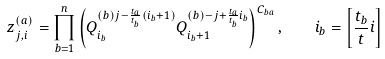<formula> <loc_0><loc_0><loc_500><loc_500>z ^ { ( a ) } _ { j , i } = \prod _ { b = 1 } ^ { n } \left ( Q ^ { ( b ) j - \frac { t _ { a } } { t _ { b } } ( i _ { b } + 1 ) } _ { i _ { b } } Q ^ { ( b ) - j + \frac { t _ { a } } { t _ { b } } i _ { b } } _ { i _ { b } + 1 } \right ) ^ { C _ { b a } } , \quad i _ { b } = \left [ \frac { t _ { b } } { t } i \right ]</formula> 